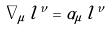Convert formula to latex. <formula><loc_0><loc_0><loc_500><loc_500>\nabla _ { \mu } \, l ^ { \nu } = \alpha _ { \mu } \, l ^ { \nu }</formula> 